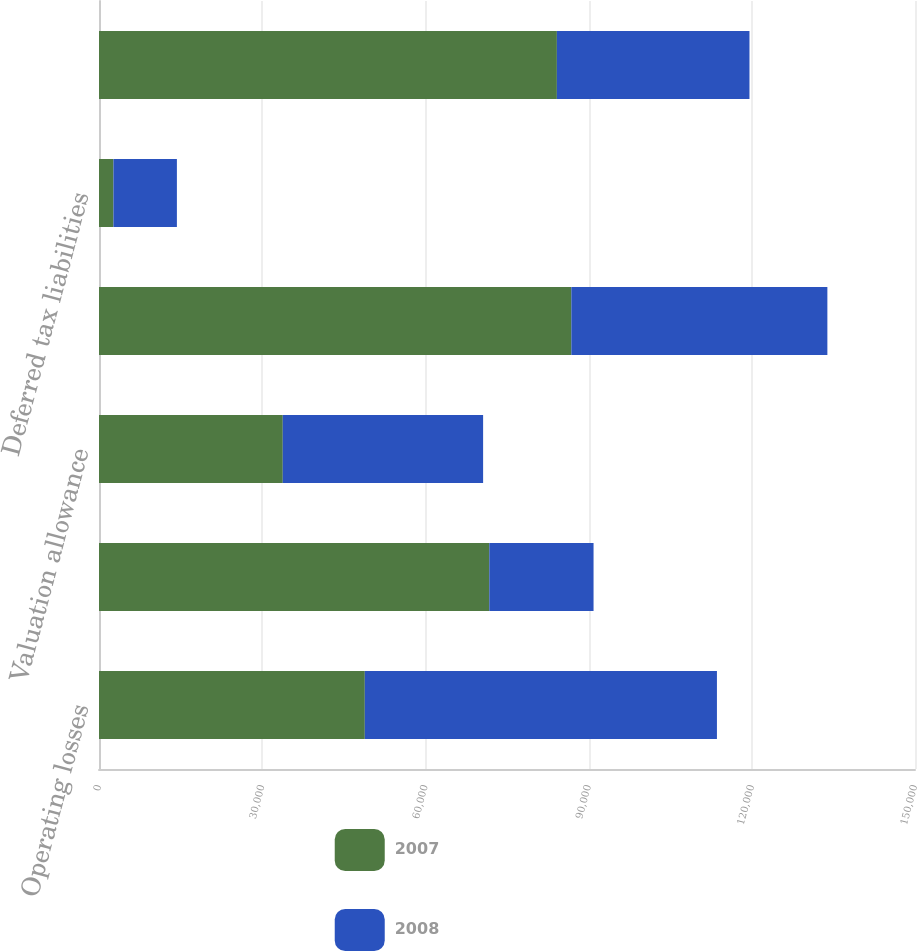Convert chart to OTSL. <chart><loc_0><loc_0><loc_500><loc_500><stacked_bar_chart><ecel><fcel>Operating losses<fcel>Other<fcel>Valuation allowance<fcel>Total deferred tax assets<fcel>Deferred tax liabilities<fcel>Net deferred tax assets<nl><fcel>2007<fcel>48863<fcel>71747<fcel>33783<fcel>86827<fcel>2656<fcel>84171<nl><fcel>2008<fcel>64728<fcel>19163<fcel>36826<fcel>47065<fcel>11663<fcel>35402<nl></chart> 